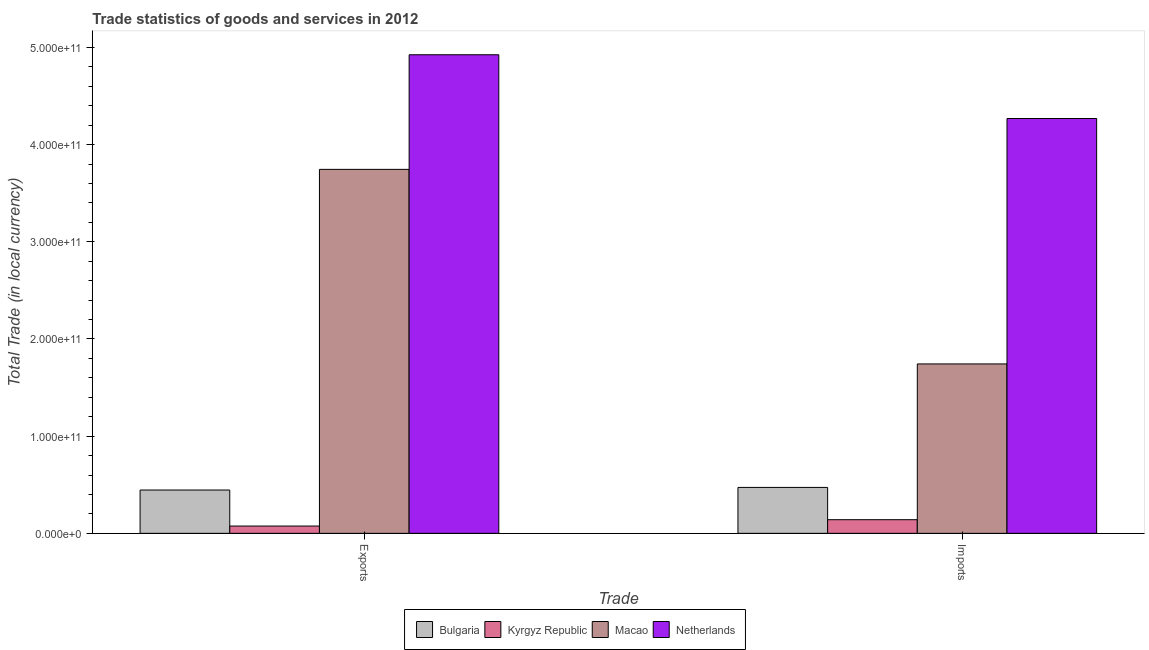How many different coloured bars are there?
Ensure brevity in your answer.  4. Are the number of bars on each tick of the X-axis equal?
Keep it short and to the point. Yes. How many bars are there on the 2nd tick from the left?
Your answer should be compact. 4. What is the label of the 1st group of bars from the left?
Offer a very short reply. Exports. What is the export of goods and services in Bulgaria?
Provide a succinct answer. 4.46e+1. Across all countries, what is the maximum export of goods and services?
Make the answer very short. 4.92e+11. Across all countries, what is the minimum export of goods and services?
Provide a succinct answer. 7.50e+09. In which country was the imports of goods and services minimum?
Offer a terse response. Kyrgyz Republic. What is the total export of goods and services in the graph?
Offer a terse response. 9.19e+11. What is the difference between the export of goods and services in Bulgaria and that in Kyrgyz Republic?
Offer a terse response. 3.71e+1. What is the difference between the imports of goods and services in Netherlands and the export of goods and services in Macao?
Your answer should be compact. 5.24e+1. What is the average export of goods and services per country?
Provide a short and direct response. 2.30e+11. What is the difference between the imports of goods and services and export of goods and services in Macao?
Your answer should be very brief. -2.00e+11. In how many countries, is the export of goods and services greater than 20000000000 LCU?
Ensure brevity in your answer.  3. What is the ratio of the export of goods and services in Netherlands to that in Bulgaria?
Offer a very short reply. 11.05. Is the imports of goods and services in Bulgaria less than that in Macao?
Make the answer very short. Yes. What does the 4th bar from the left in Exports represents?
Give a very brief answer. Netherlands. What does the 1st bar from the right in Exports represents?
Offer a terse response. Netherlands. How many bars are there?
Offer a terse response. 8. Are all the bars in the graph horizontal?
Make the answer very short. No. How many countries are there in the graph?
Keep it short and to the point. 4. What is the difference between two consecutive major ticks on the Y-axis?
Your response must be concise. 1.00e+11. Are the values on the major ticks of Y-axis written in scientific E-notation?
Keep it short and to the point. Yes. Does the graph contain any zero values?
Your answer should be compact. No. How are the legend labels stacked?
Provide a succinct answer. Horizontal. What is the title of the graph?
Make the answer very short. Trade statistics of goods and services in 2012. What is the label or title of the X-axis?
Your answer should be very brief. Trade. What is the label or title of the Y-axis?
Ensure brevity in your answer.  Total Trade (in local currency). What is the Total Trade (in local currency) in Bulgaria in Exports?
Make the answer very short. 4.46e+1. What is the Total Trade (in local currency) of Kyrgyz Republic in Exports?
Your response must be concise. 7.50e+09. What is the Total Trade (in local currency) of Macao in Exports?
Your response must be concise. 3.74e+11. What is the Total Trade (in local currency) of Netherlands in Exports?
Your answer should be compact. 4.92e+11. What is the Total Trade (in local currency) in Bulgaria in Imports?
Ensure brevity in your answer.  4.73e+1. What is the Total Trade (in local currency) in Kyrgyz Republic in Imports?
Provide a succinct answer. 1.40e+1. What is the Total Trade (in local currency) of Macao in Imports?
Provide a short and direct response. 1.74e+11. What is the Total Trade (in local currency) of Netherlands in Imports?
Provide a short and direct response. 4.27e+11. Across all Trade, what is the maximum Total Trade (in local currency) in Bulgaria?
Provide a short and direct response. 4.73e+1. Across all Trade, what is the maximum Total Trade (in local currency) of Kyrgyz Republic?
Ensure brevity in your answer.  1.40e+1. Across all Trade, what is the maximum Total Trade (in local currency) of Macao?
Your answer should be very brief. 3.74e+11. Across all Trade, what is the maximum Total Trade (in local currency) in Netherlands?
Make the answer very short. 4.92e+11. Across all Trade, what is the minimum Total Trade (in local currency) of Bulgaria?
Your answer should be very brief. 4.46e+1. Across all Trade, what is the minimum Total Trade (in local currency) in Kyrgyz Republic?
Make the answer very short. 7.50e+09. Across all Trade, what is the minimum Total Trade (in local currency) of Macao?
Keep it short and to the point. 1.74e+11. Across all Trade, what is the minimum Total Trade (in local currency) in Netherlands?
Keep it short and to the point. 4.27e+11. What is the total Total Trade (in local currency) in Bulgaria in the graph?
Give a very brief answer. 9.18e+1. What is the total Total Trade (in local currency) of Kyrgyz Republic in the graph?
Offer a very short reply. 2.15e+1. What is the total Total Trade (in local currency) of Macao in the graph?
Keep it short and to the point. 5.49e+11. What is the total Total Trade (in local currency) in Netherlands in the graph?
Your answer should be compact. 9.19e+11. What is the difference between the Total Trade (in local currency) in Bulgaria in Exports and that in Imports?
Provide a succinct answer. -2.70e+09. What is the difference between the Total Trade (in local currency) in Kyrgyz Republic in Exports and that in Imports?
Provide a succinct answer. -6.53e+09. What is the difference between the Total Trade (in local currency) of Macao in Exports and that in Imports?
Offer a terse response. 2.00e+11. What is the difference between the Total Trade (in local currency) of Netherlands in Exports and that in Imports?
Your answer should be very brief. 6.56e+1. What is the difference between the Total Trade (in local currency) in Bulgaria in Exports and the Total Trade (in local currency) in Kyrgyz Republic in Imports?
Keep it short and to the point. 3.05e+1. What is the difference between the Total Trade (in local currency) of Bulgaria in Exports and the Total Trade (in local currency) of Macao in Imports?
Ensure brevity in your answer.  -1.30e+11. What is the difference between the Total Trade (in local currency) of Bulgaria in Exports and the Total Trade (in local currency) of Netherlands in Imports?
Offer a terse response. -3.82e+11. What is the difference between the Total Trade (in local currency) of Kyrgyz Republic in Exports and the Total Trade (in local currency) of Macao in Imports?
Offer a terse response. -1.67e+11. What is the difference between the Total Trade (in local currency) of Kyrgyz Republic in Exports and the Total Trade (in local currency) of Netherlands in Imports?
Offer a terse response. -4.19e+11. What is the difference between the Total Trade (in local currency) in Macao in Exports and the Total Trade (in local currency) in Netherlands in Imports?
Offer a very short reply. -5.24e+1. What is the average Total Trade (in local currency) in Bulgaria per Trade?
Offer a terse response. 4.59e+1. What is the average Total Trade (in local currency) in Kyrgyz Republic per Trade?
Offer a terse response. 1.08e+1. What is the average Total Trade (in local currency) in Macao per Trade?
Offer a terse response. 2.74e+11. What is the average Total Trade (in local currency) in Netherlands per Trade?
Give a very brief answer. 4.60e+11. What is the difference between the Total Trade (in local currency) in Bulgaria and Total Trade (in local currency) in Kyrgyz Republic in Exports?
Make the answer very short. 3.71e+1. What is the difference between the Total Trade (in local currency) in Bulgaria and Total Trade (in local currency) in Macao in Exports?
Provide a short and direct response. -3.30e+11. What is the difference between the Total Trade (in local currency) of Bulgaria and Total Trade (in local currency) of Netherlands in Exports?
Make the answer very short. -4.48e+11. What is the difference between the Total Trade (in local currency) in Kyrgyz Republic and Total Trade (in local currency) in Macao in Exports?
Provide a succinct answer. -3.67e+11. What is the difference between the Total Trade (in local currency) in Kyrgyz Republic and Total Trade (in local currency) in Netherlands in Exports?
Offer a very short reply. -4.85e+11. What is the difference between the Total Trade (in local currency) in Macao and Total Trade (in local currency) in Netherlands in Exports?
Keep it short and to the point. -1.18e+11. What is the difference between the Total Trade (in local currency) of Bulgaria and Total Trade (in local currency) of Kyrgyz Republic in Imports?
Your answer should be compact. 3.32e+1. What is the difference between the Total Trade (in local currency) of Bulgaria and Total Trade (in local currency) of Macao in Imports?
Offer a very short reply. -1.27e+11. What is the difference between the Total Trade (in local currency) of Bulgaria and Total Trade (in local currency) of Netherlands in Imports?
Give a very brief answer. -3.80e+11. What is the difference between the Total Trade (in local currency) in Kyrgyz Republic and Total Trade (in local currency) in Macao in Imports?
Offer a very short reply. -1.60e+11. What is the difference between the Total Trade (in local currency) in Kyrgyz Republic and Total Trade (in local currency) in Netherlands in Imports?
Offer a terse response. -4.13e+11. What is the difference between the Total Trade (in local currency) in Macao and Total Trade (in local currency) in Netherlands in Imports?
Make the answer very short. -2.53e+11. What is the ratio of the Total Trade (in local currency) of Bulgaria in Exports to that in Imports?
Provide a short and direct response. 0.94. What is the ratio of the Total Trade (in local currency) of Kyrgyz Republic in Exports to that in Imports?
Provide a short and direct response. 0.53. What is the ratio of the Total Trade (in local currency) of Macao in Exports to that in Imports?
Provide a succinct answer. 2.15. What is the ratio of the Total Trade (in local currency) in Netherlands in Exports to that in Imports?
Your response must be concise. 1.15. What is the difference between the highest and the second highest Total Trade (in local currency) of Bulgaria?
Offer a very short reply. 2.70e+09. What is the difference between the highest and the second highest Total Trade (in local currency) of Kyrgyz Republic?
Make the answer very short. 6.53e+09. What is the difference between the highest and the second highest Total Trade (in local currency) of Macao?
Provide a succinct answer. 2.00e+11. What is the difference between the highest and the second highest Total Trade (in local currency) in Netherlands?
Offer a very short reply. 6.56e+1. What is the difference between the highest and the lowest Total Trade (in local currency) of Bulgaria?
Your answer should be very brief. 2.70e+09. What is the difference between the highest and the lowest Total Trade (in local currency) in Kyrgyz Republic?
Provide a succinct answer. 6.53e+09. What is the difference between the highest and the lowest Total Trade (in local currency) in Macao?
Your answer should be very brief. 2.00e+11. What is the difference between the highest and the lowest Total Trade (in local currency) of Netherlands?
Ensure brevity in your answer.  6.56e+1. 